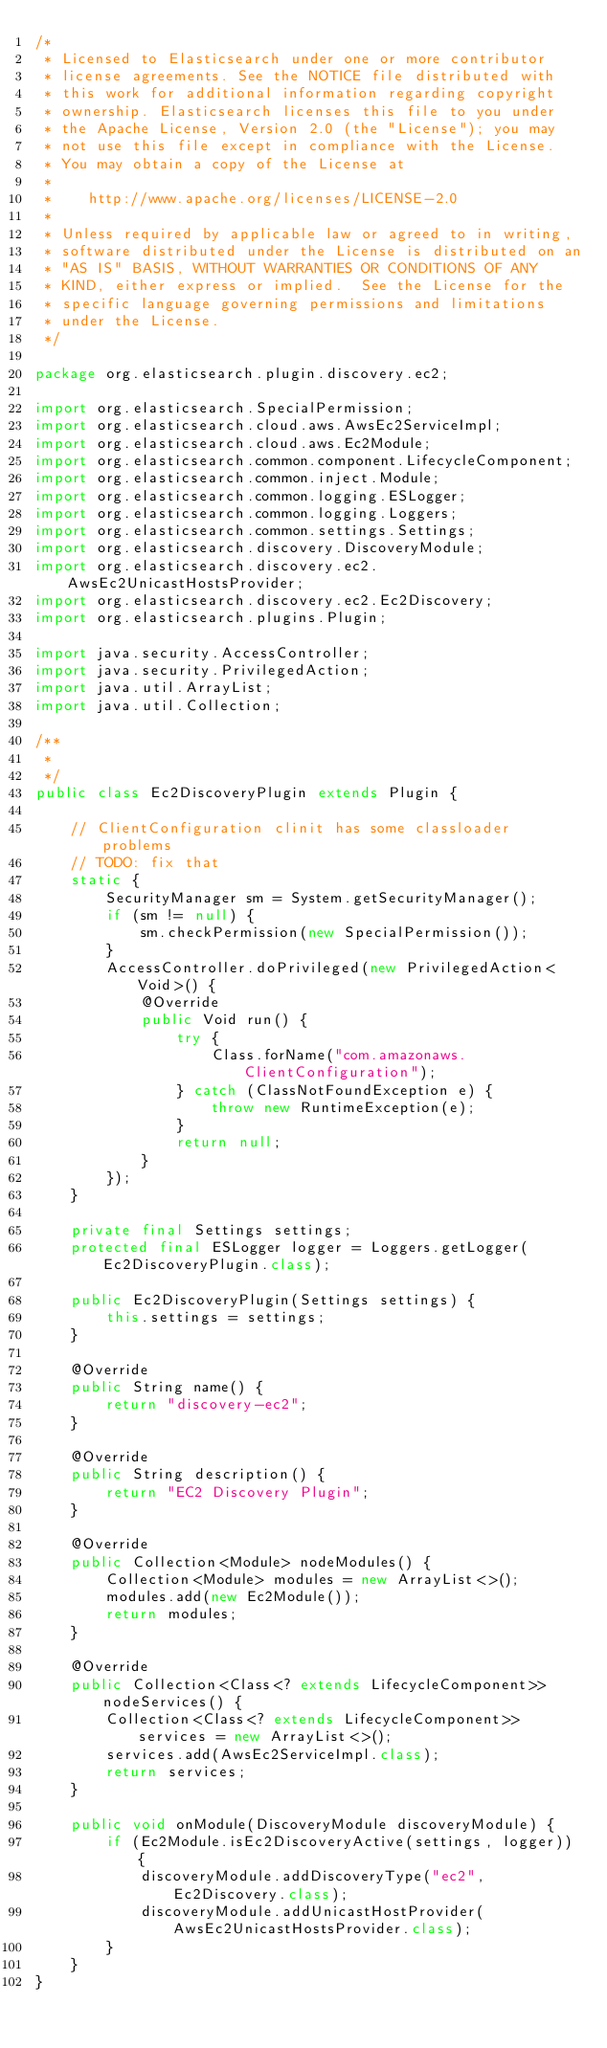<code> <loc_0><loc_0><loc_500><loc_500><_Java_>/*
 * Licensed to Elasticsearch under one or more contributor
 * license agreements. See the NOTICE file distributed with
 * this work for additional information regarding copyright
 * ownership. Elasticsearch licenses this file to you under
 * the Apache License, Version 2.0 (the "License"); you may
 * not use this file except in compliance with the License.
 * You may obtain a copy of the License at
 *
 *    http://www.apache.org/licenses/LICENSE-2.0
 *
 * Unless required by applicable law or agreed to in writing,
 * software distributed under the License is distributed on an
 * "AS IS" BASIS, WITHOUT WARRANTIES OR CONDITIONS OF ANY
 * KIND, either express or implied.  See the License for the
 * specific language governing permissions and limitations
 * under the License.
 */

package org.elasticsearch.plugin.discovery.ec2;

import org.elasticsearch.SpecialPermission;
import org.elasticsearch.cloud.aws.AwsEc2ServiceImpl;
import org.elasticsearch.cloud.aws.Ec2Module;
import org.elasticsearch.common.component.LifecycleComponent;
import org.elasticsearch.common.inject.Module;
import org.elasticsearch.common.logging.ESLogger;
import org.elasticsearch.common.logging.Loggers;
import org.elasticsearch.common.settings.Settings;
import org.elasticsearch.discovery.DiscoveryModule;
import org.elasticsearch.discovery.ec2.AwsEc2UnicastHostsProvider;
import org.elasticsearch.discovery.ec2.Ec2Discovery;
import org.elasticsearch.plugins.Plugin;

import java.security.AccessController;
import java.security.PrivilegedAction;
import java.util.ArrayList;
import java.util.Collection;

/**
 *
 */
public class Ec2DiscoveryPlugin extends Plugin {
  
    // ClientConfiguration clinit has some classloader problems
    // TODO: fix that
    static {
        SecurityManager sm = System.getSecurityManager();
        if (sm != null) {
            sm.checkPermission(new SpecialPermission());
        }
        AccessController.doPrivileged(new PrivilegedAction<Void>() {
            @Override
            public Void run() {
                try {
                    Class.forName("com.amazonaws.ClientConfiguration");
                } catch (ClassNotFoundException e) {
                    throw new RuntimeException(e);
                }
                return null;
            }
        });
    }

    private final Settings settings;
    protected final ESLogger logger = Loggers.getLogger(Ec2DiscoveryPlugin.class);

    public Ec2DiscoveryPlugin(Settings settings) {
        this.settings = settings;
    }

    @Override
    public String name() {
        return "discovery-ec2";
    }

    @Override
    public String description() {
        return "EC2 Discovery Plugin";
    }

    @Override
    public Collection<Module> nodeModules() {
        Collection<Module> modules = new ArrayList<>();
        modules.add(new Ec2Module());
        return modules;
    }

    @Override
    public Collection<Class<? extends LifecycleComponent>> nodeServices() {
        Collection<Class<? extends LifecycleComponent>> services = new ArrayList<>();
        services.add(AwsEc2ServiceImpl.class);
        return services;
    }

    public void onModule(DiscoveryModule discoveryModule) {
        if (Ec2Module.isEc2DiscoveryActive(settings, logger)) {
            discoveryModule.addDiscoveryType("ec2", Ec2Discovery.class);
            discoveryModule.addUnicastHostProvider(AwsEc2UnicastHostsProvider.class);
        }
    }
}
</code> 